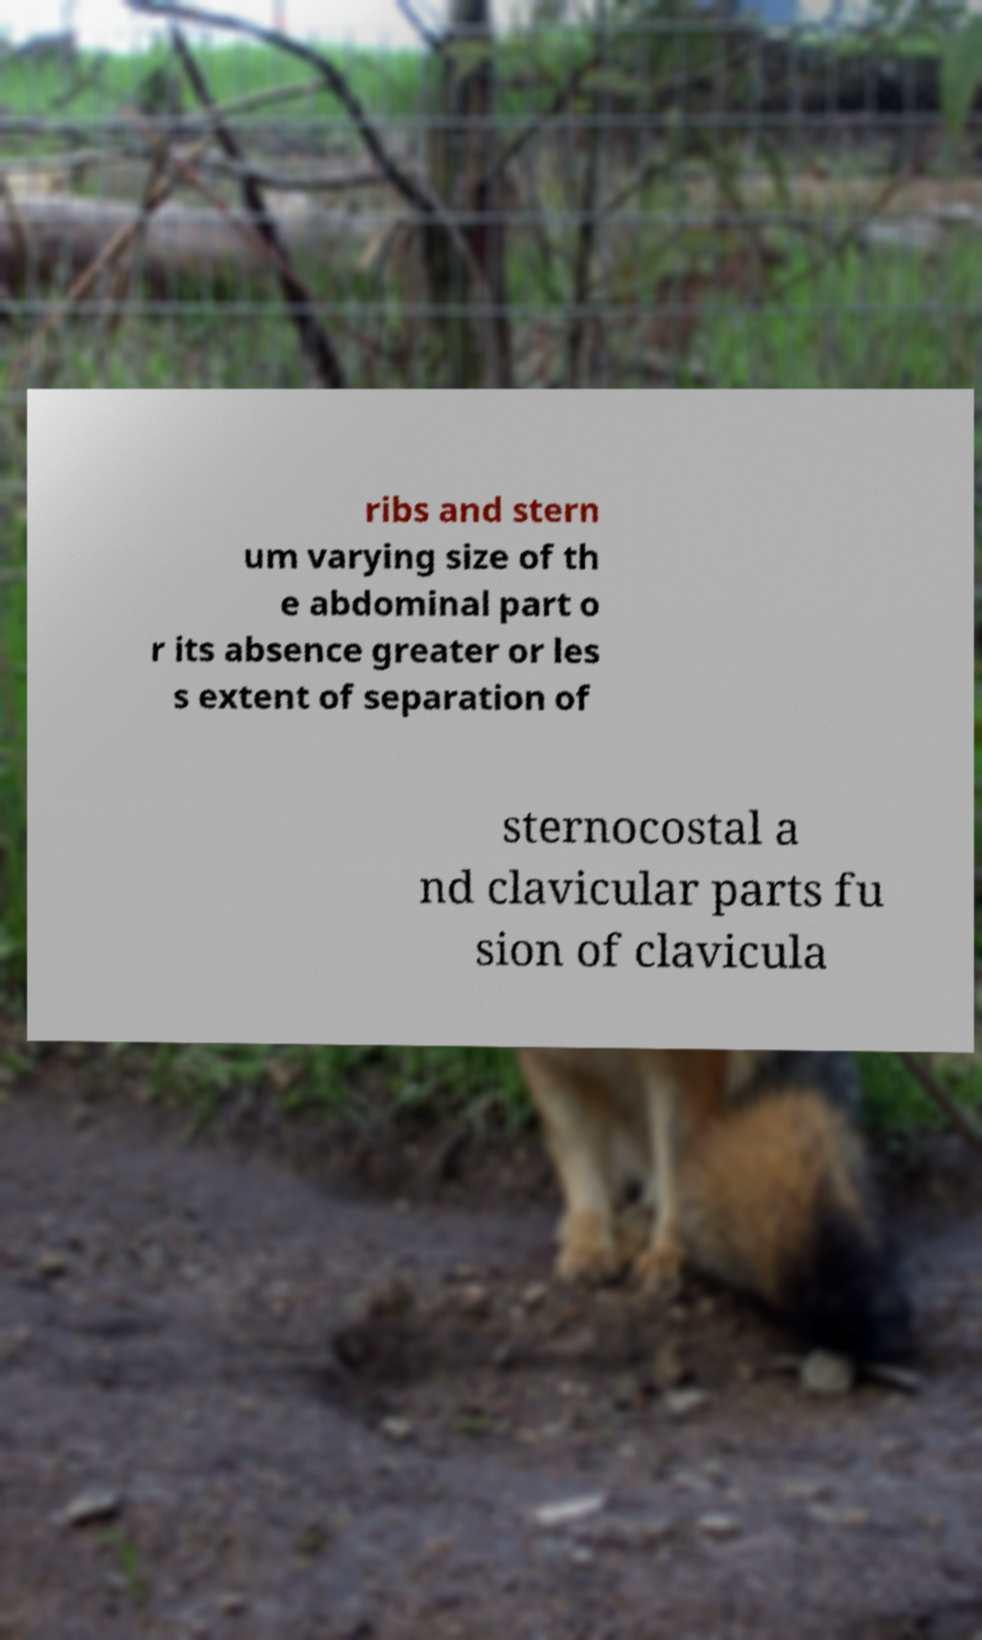What messages or text are displayed in this image? I need them in a readable, typed format. ribs and stern um varying size of th e abdominal part o r its absence greater or les s extent of separation of sternocostal a nd clavicular parts fu sion of clavicula 